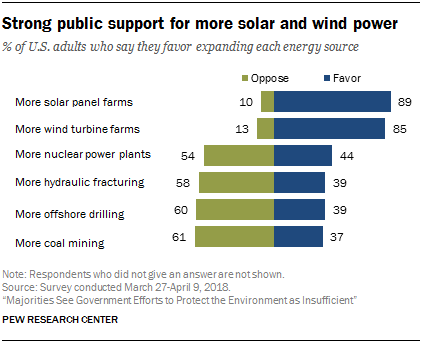Indicate a few pertinent items in this graphic. The result of taking the sum of the two smallest green bars and smallest blue bars and deducting the smaller value from the larger value is 14. Sixty-one percent of U.S. adults oppose expanding more coal mining, according to a recent survey. 